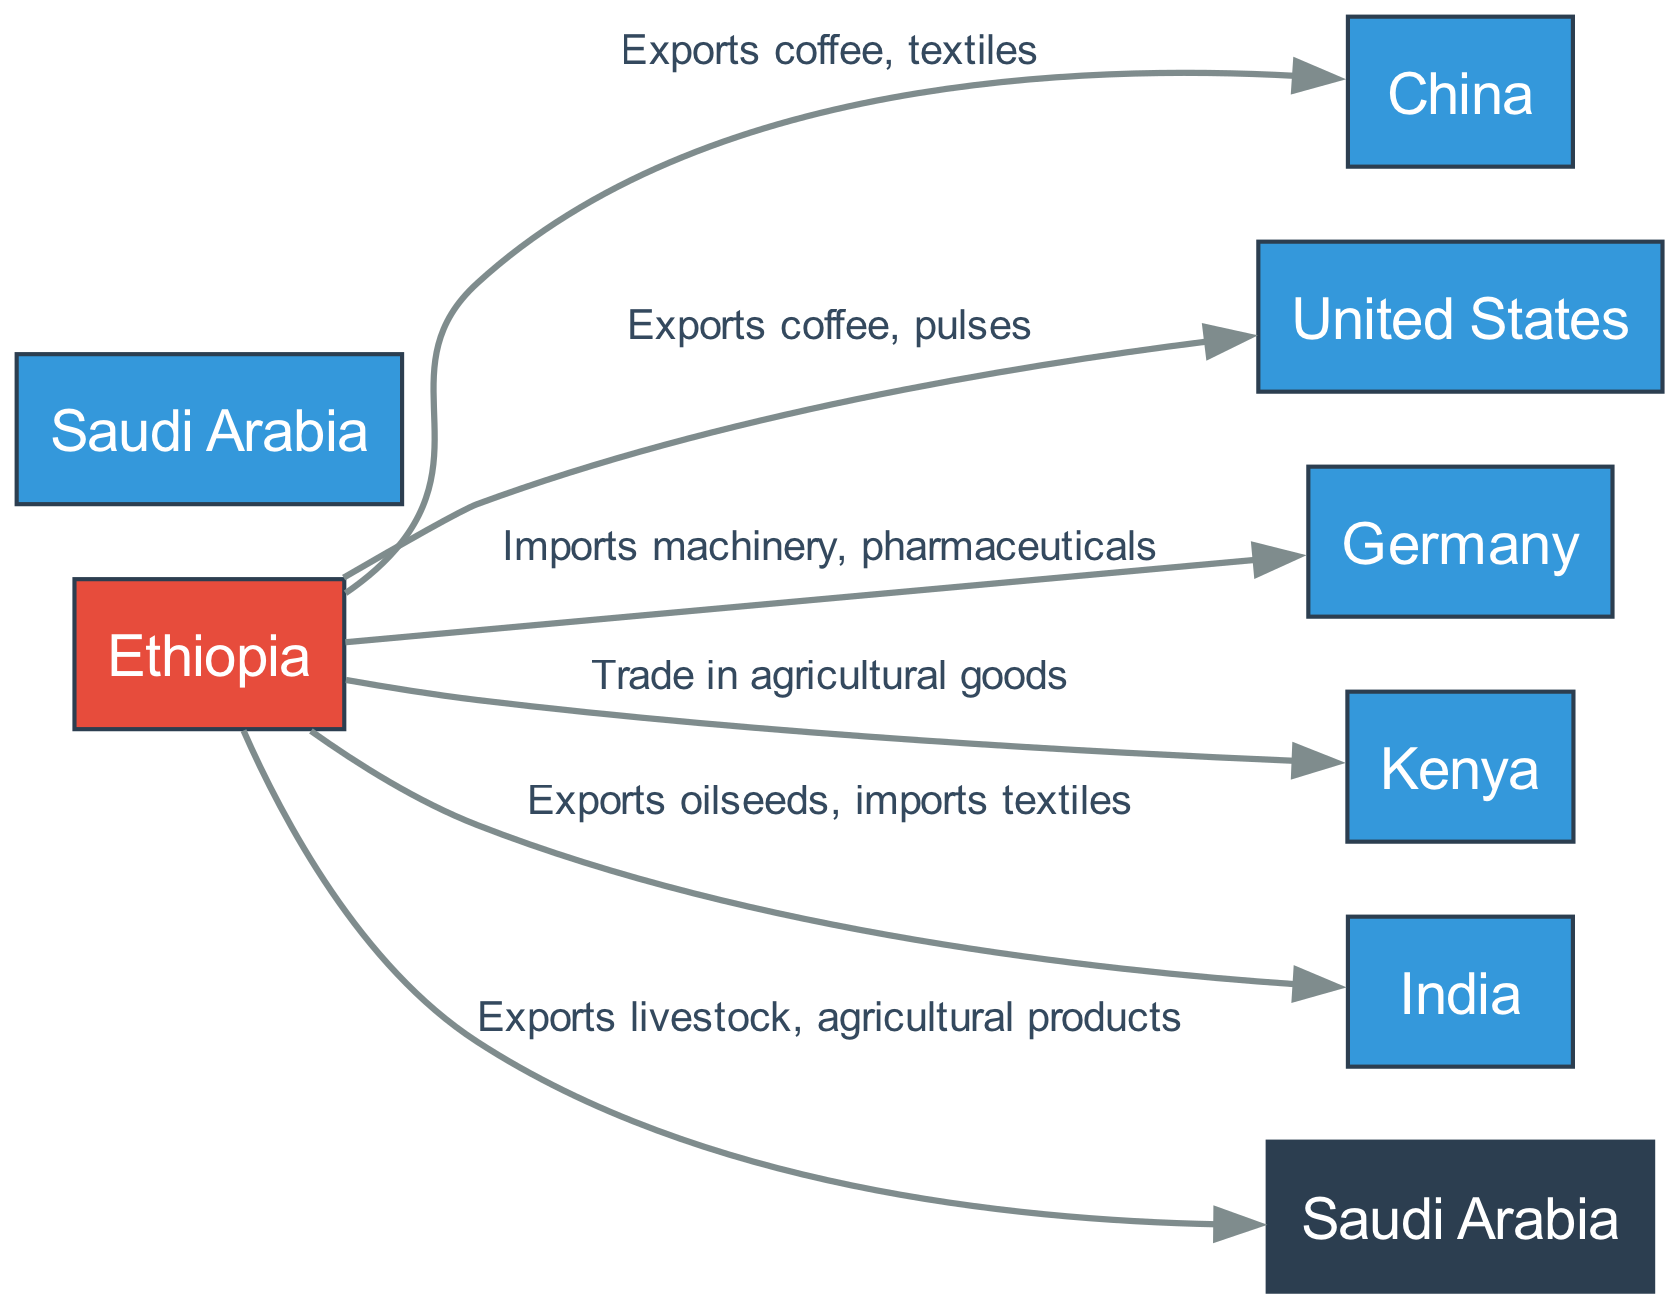What is the total number of nodes in the diagram? The diagram includes nodes for Ethiopia, China, United States, Saudi Arabia, Germany, Kenya, and India. Counting these nodes results in a total of 7 distinct nodes.
Answer: 7 Which country receives coffee and pulses from Ethiopia? The directed edge from Ethiopia going to the United States specifies that Ethiopia exports coffee and pulses to the United States.
Answer: United States What do Ethiopia and India trade? The edge from Ethiopia to India indicates that Ethiopia exports oilseeds and imports textiles from India, showcasing a bi-directional trade relationship.
Answer: Oilseeds and textiles How many countries does Ethiopia export livestock and agricultural products to? Checking the directed edges, there is only one edge showing that Ethiopia exports livestock and agricultural products specifically to Saudi Arabia.
Answer: 1 Which country imports machinery and pharmaceuticals from Ethiopia? The directed edge from Ethiopia to Germany indicates that Germany is the country importing machinery and pharmaceuticals from Ethiopia.
Answer: Germany What is the relationship between Ethiopia and Kenya? The directed edge from Ethiopia to Kenya shows there is a trade relationship in agricultural goods, illustrating mutual interests in agricultural products.
Answer: Trade in agricultural goods Which country is both an exporter and importer with Ethiopia? Looking at the export and import relationships, India is the only country mentioned that exports oilseeds to Ethiopia while also importing textiles from Ethiopia.
Answer: India How many export relationships from Ethiopia are highlighted in the diagram? By counting all the directed edges from Ethiopia to other countries, we identify 5 distinct export relationships specified in the diagram, indicating the countries Ethiopia exports to.
Answer: 5 